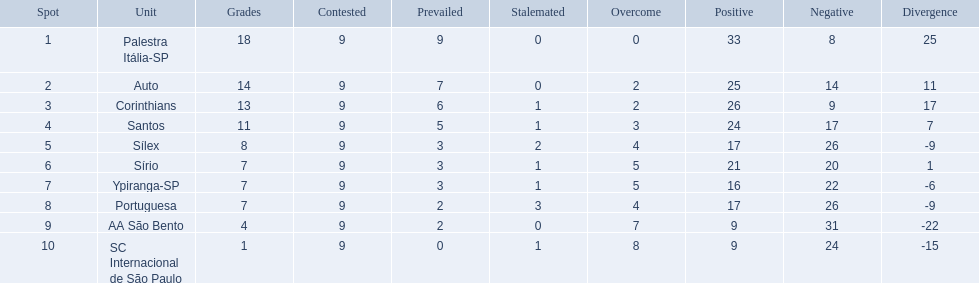Which teams were playing brazilian football in 1926? Palestra Itália-SP, Auto, Corinthians, Santos, Sílex, Sírio, Ypiranga-SP, Portuguesa, AA São Bento, SC Internacional de São Paulo. Of those teams, which one scored 13 points? Corinthians. 